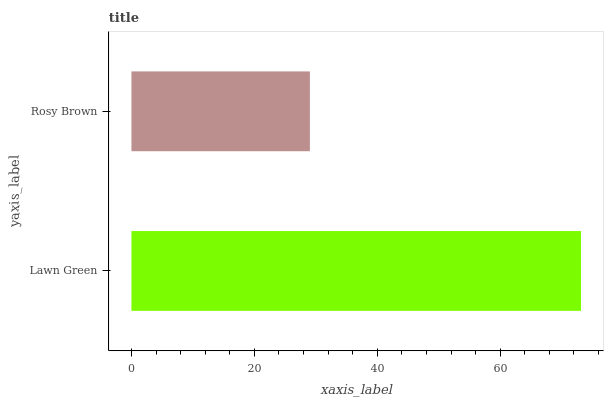Is Rosy Brown the minimum?
Answer yes or no. Yes. Is Lawn Green the maximum?
Answer yes or no. Yes. Is Rosy Brown the maximum?
Answer yes or no. No. Is Lawn Green greater than Rosy Brown?
Answer yes or no. Yes. Is Rosy Brown less than Lawn Green?
Answer yes or no. Yes. Is Rosy Brown greater than Lawn Green?
Answer yes or no. No. Is Lawn Green less than Rosy Brown?
Answer yes or no. No. Is Lawn Green the high median?
Answer yes or no. Yes. Is Rosy Brown the low median?
Answer yes or no. Yes. Is Rosy Brown the high median?
Answer yes or no. No. Is Lawn Green the low median?
Answer yes or no. No. 